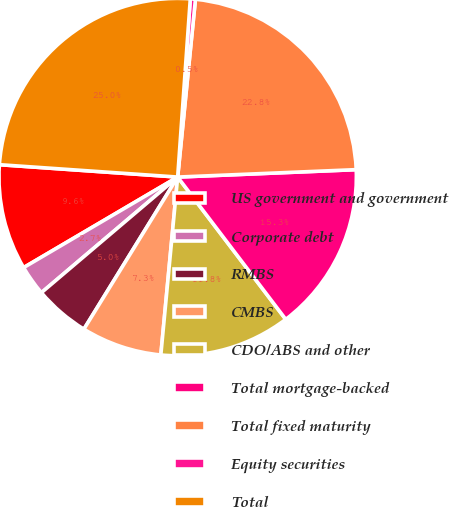Convert chart. <chart><loc_0><loc_0><loc_500><loc_500><pie_chart><fcel>US government and government<fcel>Corporate debt<fcel>RMBS<fcel>CMBS<fcel>CDO/ABS and other<fcel>Total mortgage-backed<fcel>Total fixed maturity<fcel>Equity securities<fcel>Total<nl><fcel>9.56%<fcel>2.74%<fcel>5.01%<fcel>7.29%<fcel>11.84%<fcel>15.32%<fcel>22.75%<fcel>0.46%<fcel>25.02%<nl></chart> 